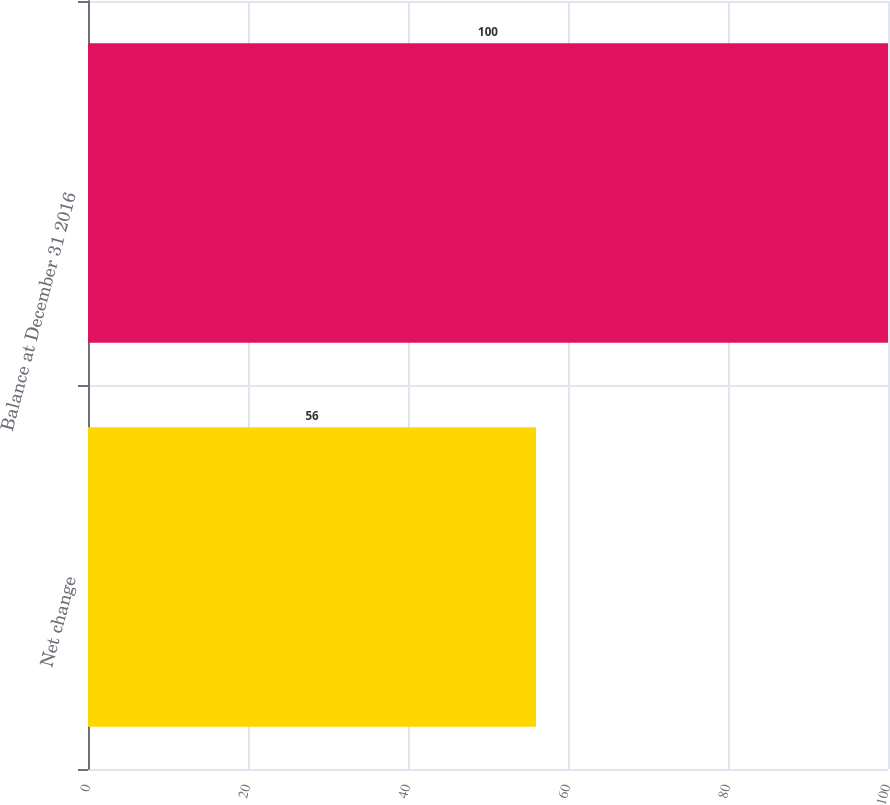Convert chart to OTSL. <chart><loc_0><loc_0><loc_500><loc_500><bar_chart><fcel>Net change<fcel>Balance at December 31 2016<nl><fcel>56<fcel>100<nl></chart> 